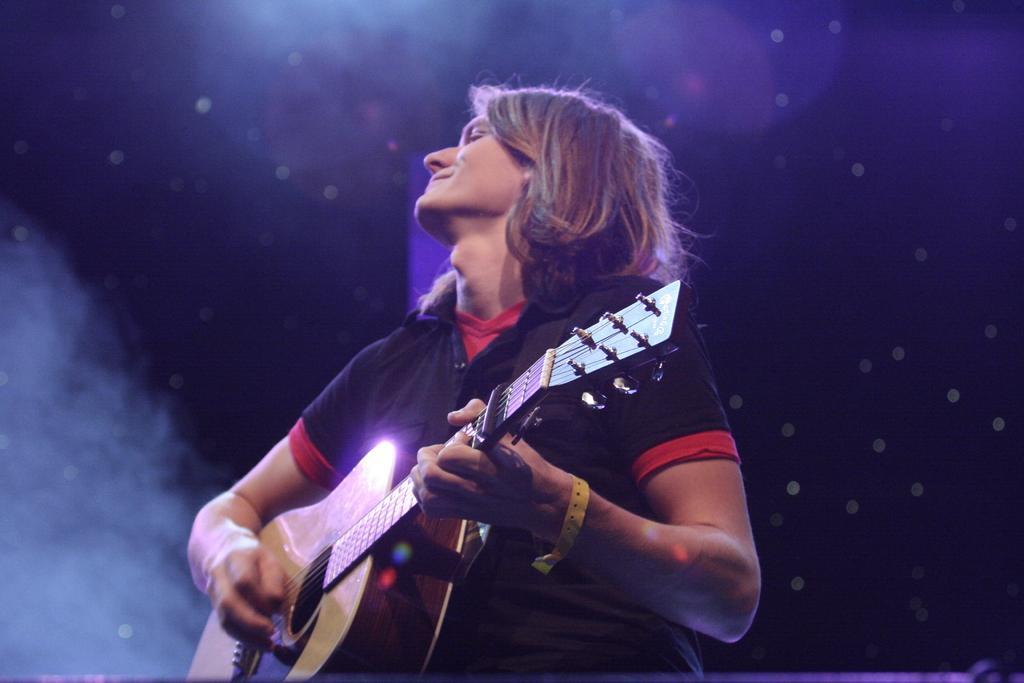How would you summarize this image in a sentence or two? In the picture a person is playing guitar. 